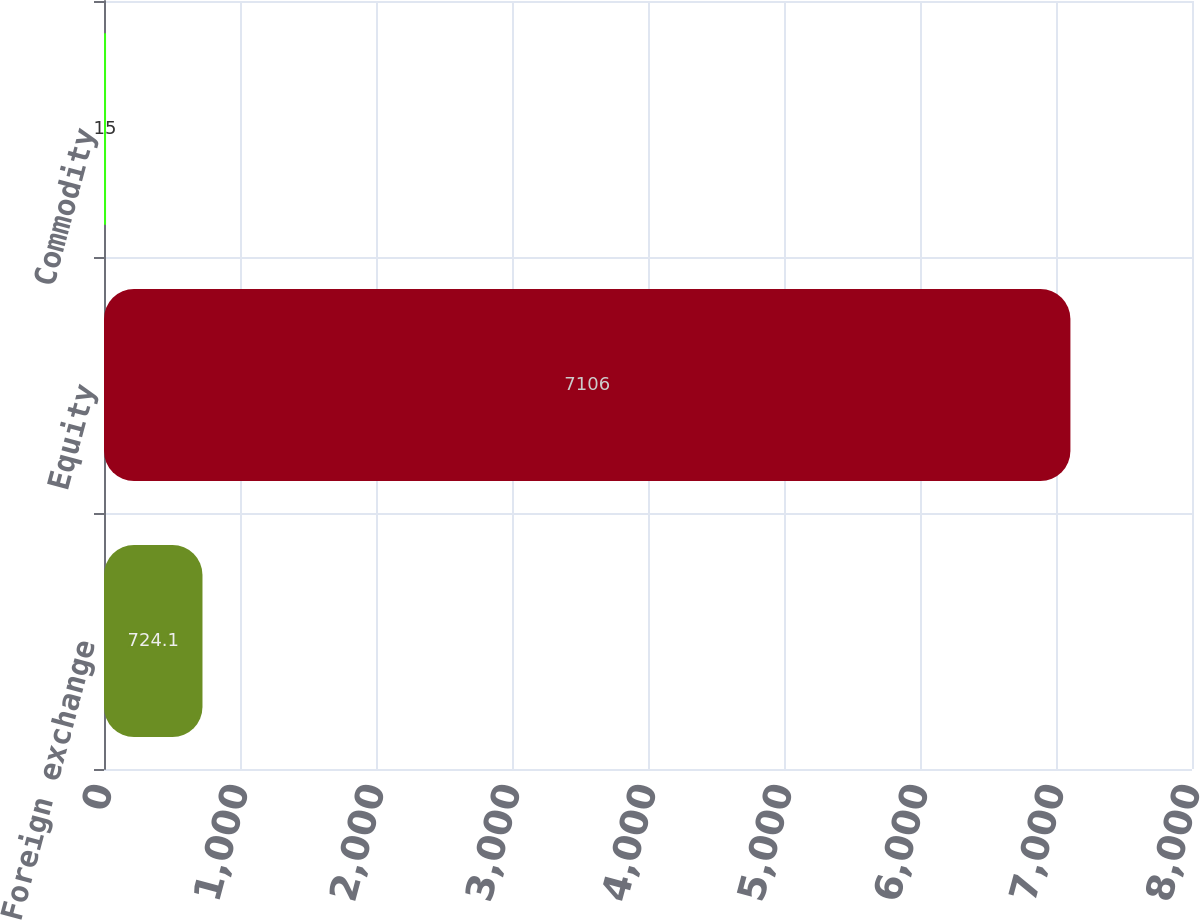<chart> <loc_0><loc_0><loc_500><loc_500><bar_chart><fcel>Foreign exchange<fcel>Equity<fcel>Commodity<nl><fcel>724.1<fcel>7106<fcel>15<nl></chart> 